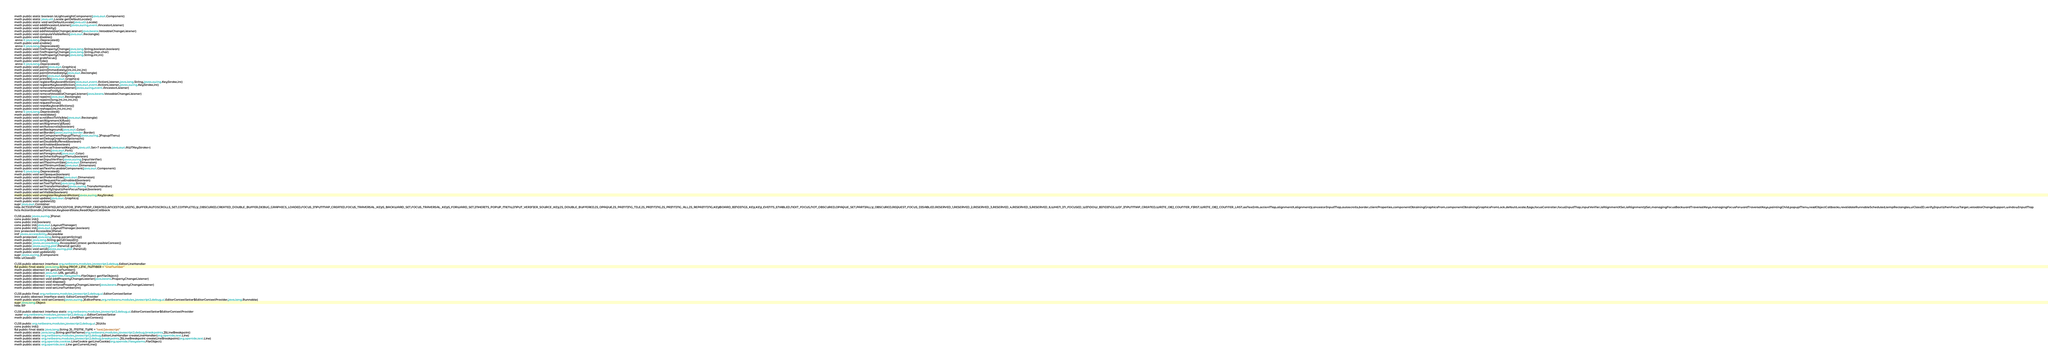<code> <loc_0><loc_0><loc_500><loc_500><_SML_>meth public static boolean isLightweightComponent(java.awt.Component)
meth public static java.util.Locale getDefaultLocale()
meth public static void setDefaultLocale(java.util.Locale)
meth public void addAncestorListener(javax.swing.event.AncestorListener)
meth public void addNotify()
meth public void addVetoableChangeListener(java.beans.VetoableChangeListener)
meth public void computeVisibleRect(java.awt.Rectangle)
meth public void disable()
 anno 0 java.lang.Deprecated()
meth public void enable()
 anno 0 java.lang.Deprecated()
meth public void firePropertyChange(java.lang.String,boolean,boolean)
meth public void firePropertyChange(java.lang.String,char,char)
meth public void firePropertyChange(java.lang.String,int,int)
meth public void grabFocus()
meth public void hide()
 anno 0 java.lang.Deprecated()
meth public void paint(java.awt.Graphics)
meth public void paintImmediately(int,int,int,int)
meth public void paintImmediately(java.awt.Rectangle)
meth public void print(java.awt.Graphics)
meth public void printAll(java.awt.Graphics)
meth public void registerKeyboardAction(java.awt.event.ActionListener,java.lang.String,javax.swing.KeyStroke,int)
meth public void registerKeyboardAction(java.awt.event.ActionListener,javax.swing.KeyStroke,int)
meth public void removeAncestorListener(javax.swing.event.AncestorListener)
meth public void removeNotify()
meth public void removeVetoableChangeListener(java.beans.VetoableChangeListener)
meth public void repaint(java.awt.Rectangle)
meth public void repaint(long,int,int,int,int)
meth public void requestFocus()
meth public void resetKeyboardActions()
meth public void reshape(int,int,int,int)
 anno 0 java.lang.Deprecated()
meth public void revalidate()
meth public void scrollRectToVisible(java.awt.Rectangle)
meth public void setAlignmentX(float)
meth public void setAlignmentY(float)
meth public void setAutoscrolls(boolean)
meth public void setBackground(java.awt.Color)
meth public void setBorder(javax.swing.border.Border)
meth public void setComponentPopupMenu(javax.swing.JPopupMenu)
meth public void setDebugGraphicsOptions(int)
meth public void setDoubleBuffered(boolean)
meth public void setEnabled(boolean)
meth public void setFocusTraversalKeys(int,java.util.Set<? extends java.awt.AWTKeyStroke>)
meth public void setFont(java.awt.Font)
meth public void setForeground(java.awt.Color)
meth public void setInheritsPopupMenu(boolean)
meth public void setInputVerifier(javax.swing.InputVerifier)
meth public void setMaximumSize(java.awt.Dimension)
meth public void setMinimumSize(java.awt.Dimension)
meth public void setNextFocusableComponent(java.awt.Component)
 anno 0 java.lang.Deprecated()
meth public void setOpaque(boolean)
meth public void setPreferredSize(java.awt.Dimension)
meth public void setRequestFocusEnabled(boolean)
meth public void setToolTipText(java.lang.String)
meth public void setTransferHandler(javax.swing.TransferHandler)
meth public void setVerifyInputWhenFocusTarget(boolean)
meth public void setVisible(boolean)
meth public void unregisterKeyboardAction(javax.swing.KeyStroke)
meth public void update(java.awt.Graphics)
meth public void updateUI()
supr java.awt.Container
hfds ACTIONMAP_CREATED,ANCESTOR_INPUTMAP_CREATED,ANCESTOR_USING_BUFFER,AUTOSCROLLS_SET,COMPLETELY_OBSCURED,CREATED_DOUBLE_BUFFER,DEBUG_GRAPHICS_LOADED,FOCUS_INPUTMAP_CREATED,FOCUS_TRAVERSAL_KEYS_BACKWARD_SET,FOCUS_TRAVERSAL_KEYS_FORWARD_SET,INHERITS_POPUP_MENU,INPUT_VERIFIER_SOURCE_KEY,IS_DOUBLE_BUFFERED,IS_OPAQUE,IS_PAINTING_TILE,IS_PRINTING,IS_PRINTING_ALL,IS_REPAINTING,KEYBOARD_BINDINGS_KEY,KEY_EVENTS_ENABLED,NEXT_FOCUS,NOT_OBSCURED,OPAQUE_SET,PARTIALLY_OBSCURED,REQUEST_FOCUS_DISABLED,RESERVED_1,RESERVED_2,RESERVED_3,RESERVED_4,RESERVED_5,RESERVED_6,WHEN_IN_FOCUSED_WINDOW_BINDINGS,WIF_INPUTMAP_CREATED,WRITE_OBJ_COUNTER_FIRST,WRITE_OBJ_COUNTER_LAST,aaTextInfo,actionMap,alignmentX,alignmentY,ancestorInputMap,autoscrolls,border,clientProperties,componentObtainingGraphicsFrom,componentObtainingGraphicsFromLock,defaultLocale,flags,focusController,focusInputMap,inputVerifier,isAlignmentXSet,isAlignmentYSet,managingFocusBackwardTraversalKeys,managingFocusForwardTraversalKeys,paintingChild,popupMenu,readObjectCallbacks,revalidateRunnableScheduled,tempRectangles,uiClassID,verifyInputWhenFocusTarget,vetoableChangeSupport,windowInputMap
hcls ActionStandin,IntVector,KeyboardState,ReadObjectCallback

CLSS public javax.swing.JPanel
cons public init()
cons public init(boolean)
cons public init(java.awt.LayoutManager)
cons public init(java.awt.LayoutManager,boolean)
innr protected AccessibleJPanel
intf javax.accessibility.Accessible
meth protected java.lang.String paramString()
meth public java.lang.String getUIClassID()
meth public javax.accessibility.AccessibleContext getAccessibleContext()
meth public javax.swing.plaf.PanelUI getUI()
meth public void setUI(javax.swing.plaf.PanelUI)
meth public void updateUI()
supr javax.swing.JComponent
hfds uiClassID

CLSS public abstract interface org.netbeans.modules.javascript2.debug.EditorLineHandler
fld public final static java.lang.String PROP_LINE_NUMBER = "lineNumber"
meth public abstract int getLineNumber()
meth public abstract java.net.URL getURL()
meth public abstract org.openide.filesystems.FileObject getFileObject()
meth public abstract void addPropertyChangeListener(java.beans.PropertyChangeListener)
meth public abstract void dispose()
meth public abstract void removePropertyChangeListener(java.beans.PropertyChangeListener)
meth public abstract void setLineNumber(int)

CLSS public final org.netbeans.modules.javascript2.debug.ui.EditorContextSetter
innr public abstract interface static EditorContextProvider
meth public static void setContext(javax.swing.JEditorPane,org.netbeans.modules.javascript2.debug.ui.EditorContextSetter$EditorContextProvider,java.lang.Runnable)
supr java.lang.Object
hfds RP

CLSS public abstract interface static org.netbeans.modules.javascript2.debug.ui.EditorContextSetter$EditorContextProvider
 outer org.netbeans.modules.javascript2.debug.ui.EditorContextSetter
meth public abstract org.openide.text.Line$Part getContext()

CLSS public org.netbeans.modules.javascript2.debug.ui.JSUtils
cons public init()
fld public final static java.lang.String JS_MIME_TYPE = "text/javascript"
meth public static java.lang.String getFileName(org.netbeans.modules.javascript2.debug.breakpoints.JSLineBreakpoint)
meth public static org.netbeans.modules.javascript2.debug.EditorLineHandler createLineHandler(org.openide.text.Line)
meth public static org.netbeans.modules.javascript2.debug.breakpoints.JSLineBreakpoint createLineBreakpoint(org.openide.text.Line)
meth public static org.openide.cookies.LineCookie getLineCookie(org.openide.filesystems.FileObject)
meth public static org.openide.text.Line getCurrentLine()</code> 